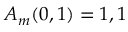Convert formula to latex. <formula><loc_0><loc_0><loc_500><loc_500>A _ { m } ( 0 , 1 ) = 1 , 1</formula> 